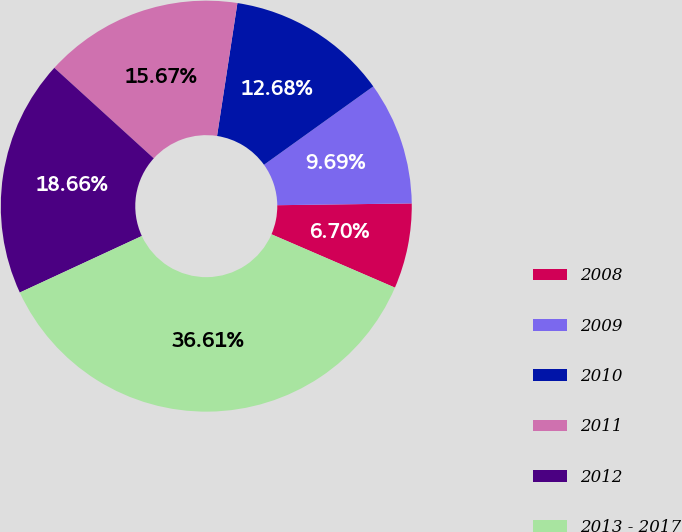<chart> <loc_0><loc_0><loc_500><loc_500><pie_chart><fcel>2008<fcel>2009<fcel>2010<fcel>2011<fcel>2012<fcel>2013 - 2017<nl><fcel>6.7%<fcel>9.69%<fcel>12.68%<fcel>15.67%<fcel>18.66%<fcel>36.61%<nl></chart> 